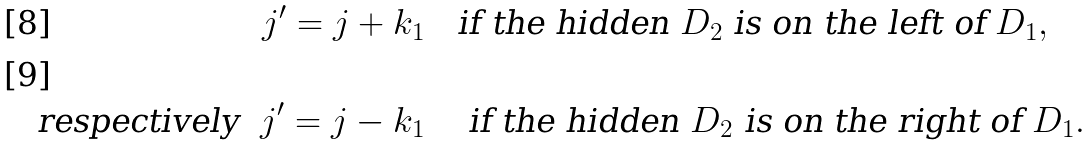<formula> <loc_0><loc_0><loc_500><loc_500>j ^ { \prime } = j + k _ { 1 } & \quad \text {if the hidden $D_{2}$ is on the left of $D_{1}$} , \\ \text {respectively} \ \ j ^ { \prime } = j - k _ { 1 } & \quad \text { if the hidden $D_{2}$ is on the right of $D_{1}$} .</formula> 